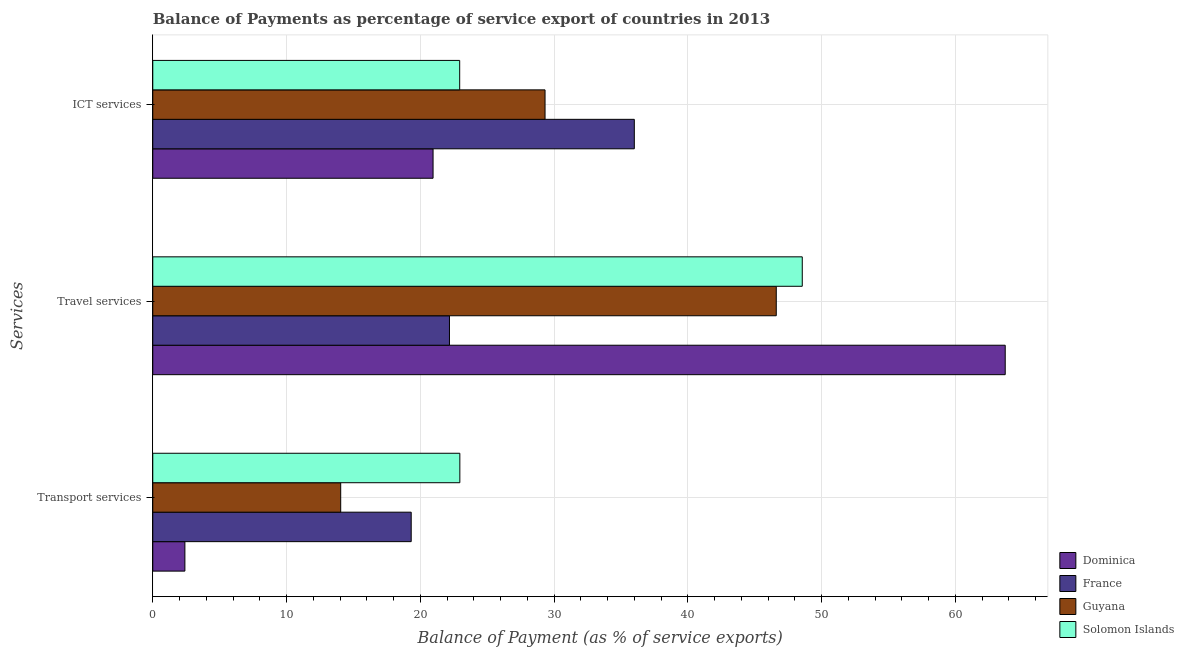How many different coloured bars are there?
Your answer should be compact. 4. How many bars are there on the 1st tick from the top?
Provide a succinct answer. 4. What is the label of the 1st group of bars from the top?
Provide a succinct answer. ICT services. What is the balance of payment of travel services in Dominica?
Your answer should be compact. 63.73. Across all countries, what is the maximum balance of payment of transport services?
Provide a short and direct response. 22.96. Across all countries, what is the minimum balance of payment of transport services?
Ensure brevity in your answer.  2.4. In which country was the balance of payment of transport services maximum?
Offer a terse response. Solomon Islands. In which country was the balance of payment of transport services minimum?
Make the answer very short. Dominica. What is the total balance of payment of ict services in the graph?
Your response must be concise. 109.23. What is the difference between the balance of payment of travel services in Dominica and that in Guyana?
Provide a succinct answer. 17.12. What is the difference between the balance of payment of ict services in Solomon Islands and the balance of payment of travel services in Dominica?
Keep it short and to the point. -40.79. What is the average balance of payment of transport services per country?
Your answer should be compact. 14.68. What is the difference between the balance of payment of travel services and balance of payment of transport services in Guyana?
Offer a very short reply. 32.56. What is the ratio of the balance of payment of ict services in Guyana to that in France?
Offer a terse response. 0.81. Is the balance of payment of transport services in France less than that in Dominica?
Your answer should be compact. No. What is the difference between the highest and the second highest balance of payment of travel services?
Give a very brief answer. 15.17. What is the difference between the highest and the lowest balance of payment of transport services?
Offer a very short reply. 20.56. In how many countries, is the balance of payment of travel services greater than the average balance of payment of travel services taken over all countries?
Keep it short and to the point. 3. Is the sum of the balance of payment of ict services in France and Solomon Islands greater than the maximum balance of payment of travel services across all countries?
Provide a succinct answer. No. What does the 2nd bar from the top in ICT services represents?
Offer a very short reply. Guyana. What does the 2nd bar from the bottom in Transport services represents?
Provide a short and direct response. France. Is it the case that in every country, the sum of the balance of payment of transport services and balance of payment of travel services is greater than the balance of payment of ict services?
Offer a terse response. Yes. What is the difference between two consecutive major ticks on the X-axis?
Offer a very short reply. 10. Are the values on the major ticks of X-axis written in scientific E-notation?
Your answer should be compact. No. Does the graph contain any zero values?
Make the answer very short. No. Does the graph contain grids?
Provide a short and direct response. Yes. Where does the legend appear in the graph?
Offer a very short reply. Bottom right. What is the title of the graph?
Keep it short and to the point. Balance of Payments as percentage of service export of countries in 2013. What is the label or title of the X-axis?
Your answer should be compact. Balance of Payment (as % of service exports). What is the label or title of the Y-axis?
Keep it short and to the point. Services. What is the Balance of Payment (as % of service exports) in Dominica in Transport services?
Your answer should be compact. 2.4. What is the Balance of Payment (as % of service exports) of France in Transport services?
Offer a terse response. 19.32. What is the Balance of Payment (as % of service exports) in Guyana in Transport services?
Make the answer very short. 14.05. What is the Balance of Payment (as % of service exports) in Solomon Islands in Transport services?
Offer a very short reply. 22.96. What is the Balance of Payment (as % of service exports) of Dominica in Travel services?
Provide a succinct answer. 63.73. What is the Balance of Payment (as % of service exports) in France in Travel services?
Give a very brief answer. 22.18. What is the Balance of Payment (as % of service exports) of Guyana in Travel services?
Provide a succinct answer. 46.61. What is the Balance of Payment (as % of service exports) of Solomon Islands in Travel services?
Keep it short and to the point. 48.56. What is the Balance of Payment (as % of service exports) of Dominica in ICT services?
Make the answer very short. 20.96. What is the Balance of Payment (as % of service exports) in France in ICT services?
Your response must be concise. 36. What is the Balance of Payment (as % of service exports) in Guyana in ICT services?
Your response must be concise. 29.33. What is the Balance of Payment (as % of service exports) in Solomon Islands in ICT services?
Make the answer very short. 22.95. Across all Services, what is the maximum Balance of Payment (as % of service exports) in Dominica?
Make the answer very short. 63.73. Across all Services, what is the maximum Balance of Payment (as % of service exports) in France?
Ensure brevity in your answer.  36. Across all Services, what is the maximum Balance of Payment (as % of service exports) of Guyana?
Provide a short and direct response. 46.61. Across all Services, what is the maximum Balance of Payment (as % of service exports) of Solomon Islands?
Give a very brief answer. 48.56. Across all Services, what is the minimum Balance of Payment (as % of service exports) of Dominica?
Your answer should be compact. 2.4. Across all Services, what is the minimum Balance of Payment (as % of service exports) in France?
Your answer should be compact. 19.32. Across all Services, what is the minimum Balance of Payment (as % of service exports) in Guyana?
Offer a terse response. 14.05. Across all Services, what is the minimum Balance of Payment (as % of service exports) in Solomon Islands?
Your answer should be compact. 22.95. What is the total Balance of Payment (as % of service exports) of Dominica in the graph?
Ensure brevity in your answer.  87.09. What is the total Balance of Payment (as % of service exports) of France in the graph?
Give a very brief answer. 77.51. What is the total Balance of Payment (as % of service exports) of Guyana in the graph?
Provide a succinct answer. 89.99. What is the total Balance of Payment (as % of service exports) of Solomon Islands in the graph?
Provide a succinct answer. 94.46. What is the difference between the Balance of Payment (as % of service exports) of Dominica in Transport services and that in Travel services?
Provide a succinct answer. -61.33. What is the difference between the Balance of Payment (as % of service exports) of France in Transport services and that in Travel services?
Your answer should be very brief. -2.86. What is the difference between the Balance of Payment (as % of service exports) of Guyana in Transport services and that in Travel services?
Offer a terse response. -32.56. What is the difference between the Balance of Payment (as % of service exports) of Solomon Islands in Transport services and that in Travel services?
Offer a very short reply. -25.6. What is the difference between the Balance of Payment (as % of service exports) in Dominica in Transport services and that in ICT services?
Your answer should be very brief. -18.55. What is the difference between the Balance of Payment (as % of service exports) of France in Transport services and that in ICT services?
Your answer should be very brief. -16.68. What is the difference between the Balance of Payment (as % of service exports) of Guyana in Transport services and that in ICT services?
Offer a terse response. -15.28. What is the difference between the Balance of Payment (as % of service exports) in Solomon Islands in Transport services and that in ICT services?
Make the answer very short. 0.01. What is the difference between the Balance of Payment (as % of service exports) in Dominica in Travel services and that in ICT services?
Provide a succinct answer. 42.78. What is the difference between the Balance of Payment (as % of service exports) in France in Travel services and that in ICT services?
Make the answer very short. -13.82. What is the difference between the Balance of Payment (as % of service exports) in Guyana in Travel services and that in ICT services?
Offer a terse response. 17.29. What is the difference between the Balance of Payment (as % of service exports) of Solomon Islands in Travel services and that in ICT services?
Provide a short and direct response. 25.61. What is the difference between the Balance of Payment (as % of service exports) of Dominica in Transport services and the Balance of Payment (as % of service exports) of France in Travel services?
Your response must be concise. -19.78. What is the difference between the Balance of Payment (as % of service exports) of Dominica in Transport services and the Balance of Payment (as % of service exports) of Guyana in Travel services?
Offer a terse response. -44.21. What is the difference between the Balance of Payment (as % of service exports) of Dominica in Transport services and the Balance of Payment (as % of service exports) of Solomon Islands in Travel services?
Provide a succinct answer. -46.16. What is the difference between the Balance of Payment (as % of service exports) of France in Transport services and the Balance of Payment (as % of service exports) of Guyana in Travel services?
Provide a succinct answer. -27.29. What is the difference between the Balance of Payment (as % of service exports) in France in Transport services and the Balance of Payment (as % of service exports) in Solomon Islands in Travel services?
Keep it short and to the point. -29.24. What is the difference between the Balance of Payment (as % of service exports) of Guyana in Transport services and the Balance of Payment (as % of service exports) of Solomon Islands in Travel services?
Provide a succinct answer. -34.51. What is the difference between the Balance of Payment (as % of service exports) of Dominica in Transport services and the Balance of Payment (as % of service exports) of France in ICT services?
Give a very brief answer. -33.6. What is the difference between the Balance of Payment (as % of service exports) of Dominica in Transport services and the Balance of Payment (as % of service exports) of Guyana in ICT services?
Provide a short and direct response. -26.93. What is the difference between the Balance of Payment (as % of service exports) in Dominica in Transport services and the Balance of Payment (as % of service exports) in Solomon Islands in ICT services?
Offer a very short reply. -20.54. What is the difference between the Balance of Payment (as % of service exports) of France in Transport services and the Balance of Payment (as % of service exports) of Guyana in ICT services?
Offer a terse response. -10.01. What is the difference between the Balance of Payment (as % of service exports) of France in Transport services and the Balance of Payment (as % of service exports) of Solomon Islands in ICT services?
Your answer should be very brief. -3.63. What is the difference between the Balance of Payment (as % of service exports) in Guyana in Transport services and the Balance of Payment (as % of service exports) in Solomon Islands in ICT services?
Ensure brevity in your answer.  -8.9. What is the difference between the Balance of Payment (as % of service exports) of Dominica in Travel services and the Balance of Payment (as % of service exports) of France in ICT services?
Provide a succinct answer. 27.73. What is the difference between the Balance of Payment (as % of service exports) in Dominica in Travel services and the Balance of Payment (as % of service exports) in Guyana in ICT services?
Keep it short and to the point. 34.4. What is the difference between the Balance of Payment (as % of service exports) in Dominica in Travel services and the Balance of Payment (as % of service exports) in Solomon Islands in ICT services?
Provide a succinct answer. 40.79. What is the difference between the Balance of Payment (as % of service exports) of France in Travel services and the Balance of Payment (as % of service exports) of Guyana in ICT services?
Give a very brief answer. -7.15. What is the difference between the Balance of Payment (as % of service exports) in France in Travel services and the Balance of Payment (as % of service exports) in Solomon Islands in ICT services?
Offer a terse response. -0.76. What is the difference between the Balance of Payment (as % of service exports) in Guyana in Travel services and the Balance of Payment (as % of service exports) in Solomon Islands in ICT services?
Keep it short and to the point. 23.67. What is the average Balance of Payment (as % of service exports) of Dominica per Services?
Ensure brevity in your answer.  29.03. What is the average Balance of Payment (as % of service exports) of France per Services?
Ensure brevity in your answer.  25.84. What is the average Balance of Payment (as % of service exports) of Guyana per Services?
Your answer should be compact. 30. What is the average Balance of Payment (as % of service exports) in Solomon Islands per Services?
Your answer should be compact. 31.49. What is the difference between the Balance of Payment (as % of service exports) of Dominica and Balance of Payment (as % of service exports) of France in Transport services?
Provide a short and direct response. -16.92. What is the difference between the Balance of Payment (as % of service exports) in Dominica and Balance of Payment (as % of service exports) in Guyana in Transport services?
Your response must be concise. -11.65. What is the difference between the Balance of Payment (as % of service exports) in Dominica and Balance of Payment (as % of service exports) in Solomon Islands in Transport services?
Your answer should be compact. -20.56. What is the difference between the Balance of Payment (as % of service exports) of France and Balance of Payment (as % of service exports) of Guyana in Transport services?
Give a very brief answer. 5.27. What is the difference between the Balance of Payment (as % of service exports) in France and Balance of Payment (as % of service exports) in Solomon Islands in Transport services?
Provide a short and direct response. -3.64. What is the difference between the Balance of Payment (as % of service exports) in Guyana and Balance of Payment (as % of service exports) in Solomon Islands in Transport services?
Offer a very short reply. -8.91. What is the difference between the Balance of Payment (as % of service exports) in Dominica and Balance of Payment (as % of service exports) in France in Travel services?
Provide a succinct answer. 41.55. What is the difference between the Balance of Payment (as % of service exports) of Dominica and Balance of Payment (as % of service exports) of Guyana in Travel services?
Offer a terse response. 17.12. What is the difference between the Balance of Payment (as % of service exports) of Dominica and Balance of Payment (as % of service exports) of Solomon Islands in Travel services?
Your answer should be compact. 15.17. What is the difference between the Balance of Payment (as % of service exports) of France and Balance of Payment (as % of service exports) of Guyana in Travel services?
Keep it short and to the point. -24.43. What is the difference between the Balance of Payment (as % of service exports) of France and Balance of Payment (as % of service exports) of Solomon Islands in Travel services?
Keep it short and to the point. -26.38. What is the difference between the Balance of Payment (as % of service exports) in Guyana and Balance of Payment (as % of service exports) in Solomon Islands in Travel services?
Give a very brief answer. -1.94. What is the difference between the Balance of Payment (as % of service exports) in Dominica and Balance of Payment (as % of service exports) in France in ICT services?
Provide a succinct answer. -15.05. What is the difference between the Balance of Payment (as % of service exports) in Dominica and Balance of Payment (as % of service exports) in Guyana in ICT services?
Offer a very short reply. -8.37. What is the difference between the Balance of Payment (as % of service exports) in Dominica and Balance of Payment (as % of service exports) in Solomon Islands in ICT services?
Ensure brevity in your answer.  -1.99. What is the difference between the Balance of Payment (as % of service exports) of France and Balance of Payment (as % of service exports) of Guyana in ICT services?
Your answer should be compact. 6.67. What is the difference between the Balance of Payment (as % of service exports) in France and Balance of Payment (as % of service exports) in Solomon Islands in ICT services?
Ensure brevity in your answer.  13.06. What is the difference between the Balance of Payment (as % of service exports) in Guyana and Balance of Payment (as % of service exports) in Solomon Islands in ICT services?
Keep it short and to the point. 6.38. What is the ratio of the Balance of Payment (as % of service exports) in Dominica in Transport services to that in Travel services?
Offer a terse response. 0.04. What is the ratio of the Balance of Payment (as % of service exports) of France in Transport services to that in Travel services?
Make the answer very short. 0.87. What is the ratio of the Balance of Payment (as % of service exports) of Guyana in Transport services to that in Travel services?
Ensure brevity in your answer.  0.3. What is the ratio of the Balance of Payment (as % of service exports) in Solomon Islands in Transport services to that in Travel services?
Provide a succinct answer. 0.47. What is the ratio of the Balance of Payment (as % of service exports) in Dominica in Transport services to that in ICT services?
Offer a very short reply. 0.11. What is the ratio of the Balance of Payment (as % of service exports) in France in Transport services to that in ICT services?
Ensure brevity in your answer.  0.54. What is the ratio of the Balance of Payment (as % of service exports) of Guyana in Transport services to that in ICT services?
Your answer should be very brief. 0.48. What is the ratio of the Balance of Payment (as % of service exports) of Dominica in Travel services to that in ICT services?
Give a very brief answer. 3.04. What is the ratio of the Balance of Payment (as % of service exports) in France in Travel services to that in ICT services?
Your response must be concise. 0.62. What is the ratio of the Balance of Payment (as % of service exports) in Guyana in Travel services to that in ICT services?
Provide a short and direct response. 1.59. What is the ratio of the Balance of Payment (as % of service exports) of Solomon Islands in Travel services to that in ICT services?
Offer a very short reply. 2.12. What is the difference between the highest and the second highest Balance of Payment (as % of service exports) of Dominica?
Offer a terse response. 42.78. What is the difference between the highest and the second highest Balance of Payment (as % of service exports) of France?
Keep it short and to the point. 13.82. What is the difference between the highest and the second highest Balance of Payment (as % of service exports) of Guyana?
Your answer should be compact. 17.29. What is the difference between the highest and the second highest Balance of Payment (as % of service exports) in Solomon Islands?
Provide a short and direct response. 25.6. What is the difference between the highest and the lowest Balance of Payment (as % of service exports) of Dominica?
Your answer should be very brief. 61.33. What is the difference between the highest and the lowest Balance of Payment (as % of service exports) in France?
Provide a succinct answer. 16.68. What is the difference between the highest and the lowest Balance of Payment (as % of service exports) of Guyana?
Provide a succinct answer. 32.56. What is the difference between the highest and the lowest Balance of Payment (as % of service exports) of Solomon Islands?
Ensure brevity in your answer.  25.61. 